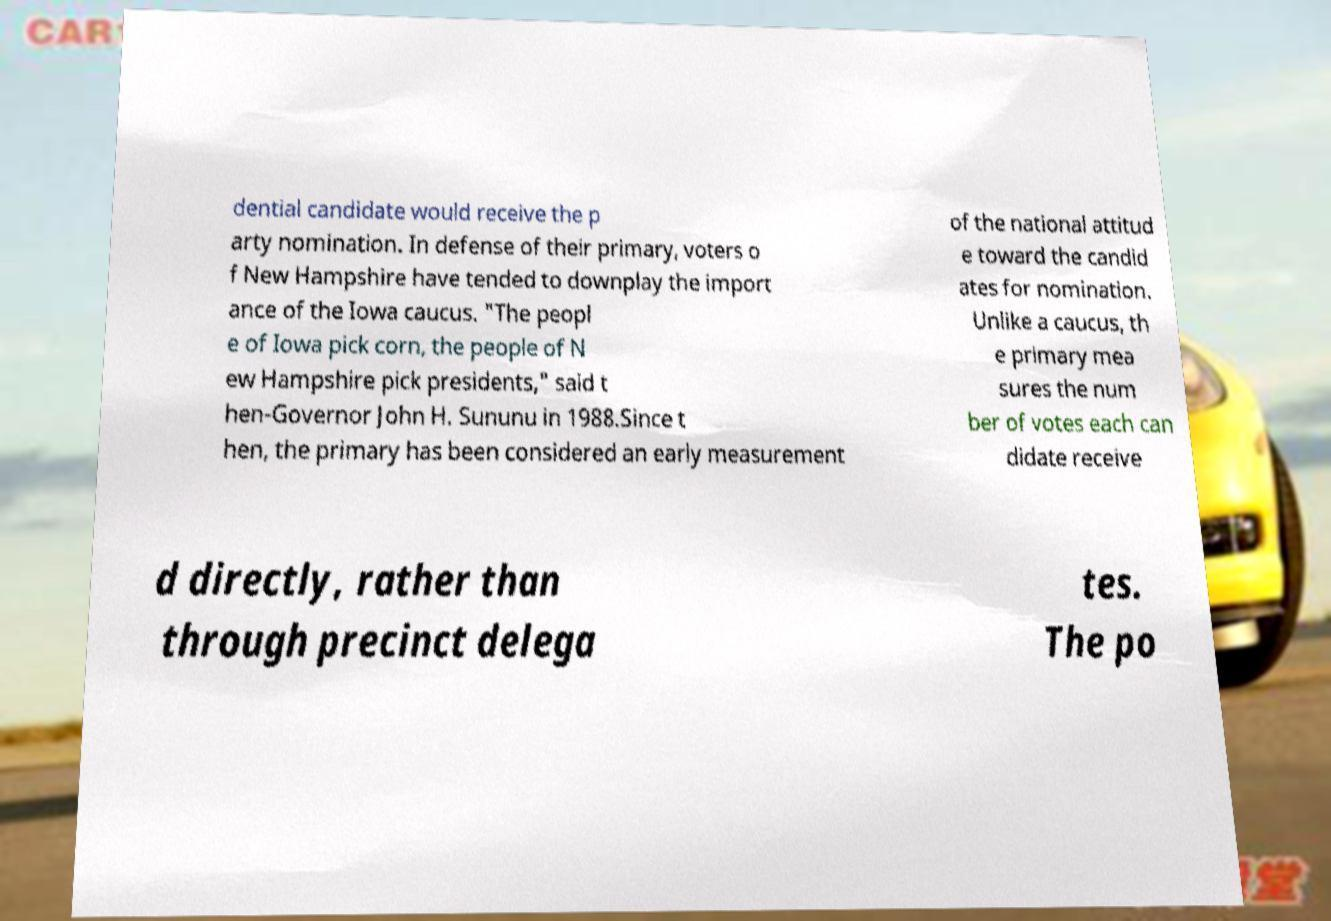What messages or text are displayed in this image? I need them in a readable, typed format. dential candidate would receive the p arty nomination. In defense of their primary, voters o f New Hampshire have tended to downplay the import ance of the Iowa caucus. "The peopl e of Iowa pick corn, the people of N ew Hampshire pick presidents," said t hen-Governor John H. Sununu in 1988.Since t hen, the primary has been considered an early measurement of the national attitud e toward the candid ates for nomination. Unlike a caucus, th e primary mea sures the num ber of votes each can didate receive d directly, rather than through precinct delega tes. The po 